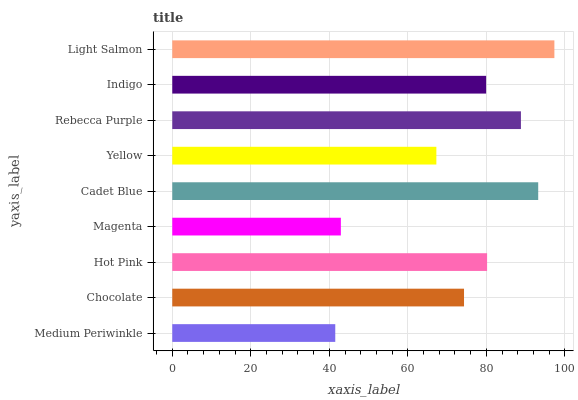Is Medium Periwinkle the minimum?
Answer yes or no. Yes. Is Light Salmon the maximum?
Answer yes or no. Yes. Is Chocolate the minimum?
Answer yes or no. No. Is Chocolate the maximum?
Answer yes or no. No. Is Chocolate greater than Medium Periwinkle?
Answer yes or no. Yes. Is Medium Periwinkle less than Chocolate?
Answer yes or no. Yes. Is Medium Periwinkle greater than Chocolate?
Answer yes or no. No. Is Chocolate less than Medium Periwinkle?
Answer yes or no. No. Is Indigo the high median?
Answer yes or no. Yes. Is Indigo the low median?
Answer yes or no. Yes. Is Cadet Blue the high median?
Answer yes or no. No. Is Rebecca Purple the low median?
Answer yes or no. No. 